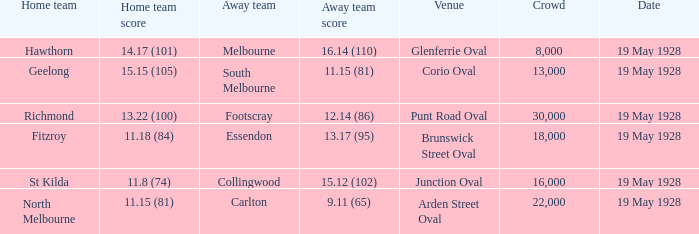What venue featured a crowd of over 30,000? None. 